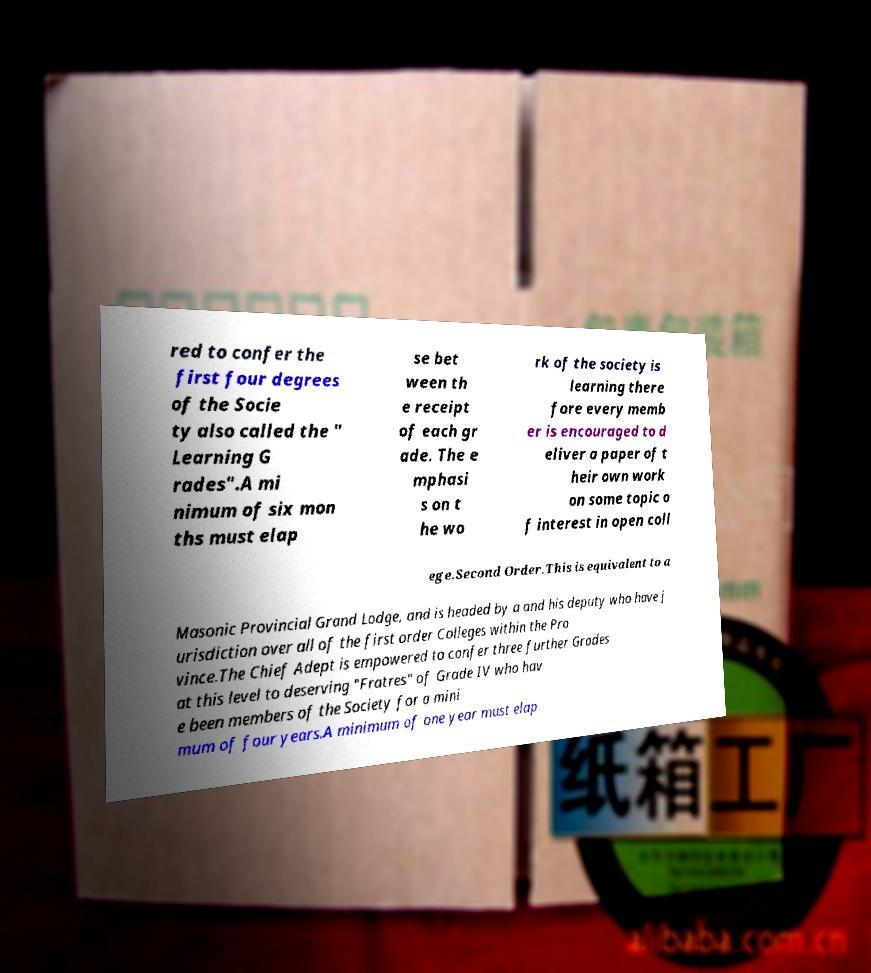What messages or text are displayed in this image? I need them in a readable, typed format. red to confer the first four degrees of the Socie ty also called the " Learning G rades".A mi nimum of six mon ths must elap se bet ween th e receipt of each gr ade. The e mphasi s on t he wo rk of the society is learning there fore every memb er is encouraged to d eliver a paper of t heir own work on some topic o f interest in open coll ege.Second Order.This is equivalent to a Masonic Provincial Grand Lodge, and is headed by a and his deputy who have j urisdiction over all of the first order Colleges within the Pro vince.The Chief Adept is empowered to confer three further Grades at this level to deserving "Fratres" of Grade IV who hav e been members of the Society for a mini mum of four years.A minimum of one year must elap 